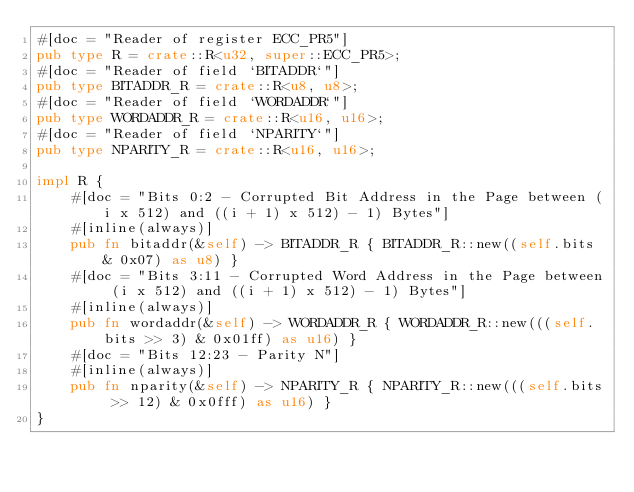<code> <loc_0><loc_0><loc_500><loc_500><_Rust_>#[doc = "Reader of register ECC_PR5"]
pub type R = crate::R<u32, super::ECC_PR5>;
#[doc = "Reader of field `BITADDR`"]
pub type BITADDR_R = crate::R<u8, u8>;
#[doc = "Reader of field `WORDADDR`"]
pub type WORDADDR_R = crate::R<u16, u16>;
#[doc = "Reader of field `NPARITY`"]
pub type NPARITY_R = crate::R<u16, u16>;

impl R {
    #[doc = "Bits 0:2 - Corrupted Bit Address in the Page between (i x 512) and ((i + 1) x 512) - 1) Bytes"]
    #[inline(always)]
    pub fn bitaddr(&self) -> BITADDR_R { BITADDR_R::new((self.bits & 0x07) as u8) }
    #[doc = "Bits 3:11 - Corrupted Word Address in the Page between (i x 512) and ((i + 1) x 512) - 1) Bytes"]
    #[inline(always)]
    pub fn wordaddr(&self) -> WORDADDR_R { WORDADDR_R::new(((self.bits >> 3) & 0x01ff) as u16) }
    #[doc = "Bits 12:23 - Parity N"]
    #[inline(always)]
    pub fn nparity(&self) -> NPARITY_R { NPARITY_R::new(((self.bits >> 12) & 0x0fff) as u16) }
}</code> 